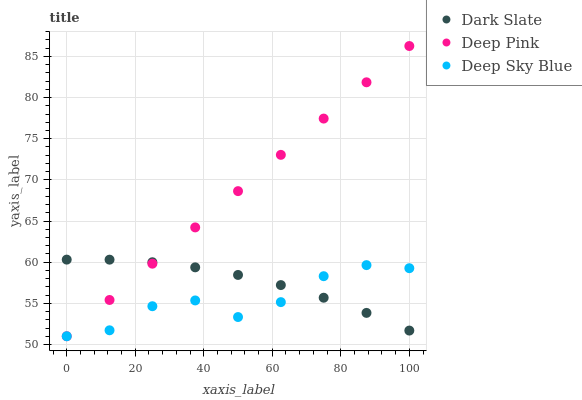Does Deep Sky Blue have the minimum area under the curve?
Answer yes or no. Yes. Does Deep Pink have the maximum area under the curve?
Answer yes or no. Yes. Does Deep Pink have the minimum area under the curve?
Answer yes or no. No. Does Deep Sky Blue have the maximum area under the curve?
Answer yes or no. No. Is Deep Pink the smoothest?
Answer yes or no. Yes. Is Deep Sky Blue the roughest?
Answer yes or no. Yes. Is Deep Sky Blue the smoothest?
Answer yes or no. No. Is Deep Pink the roughest?
Answer yes or no. No. Does Deep Pink have the lowest value?
Answer yes or no. Yes. Does Deep Pink have the highest value?
Answer yes or no. Yes. Does Deep Sky Blue have the highest value?
Answer yes or no. No. Does Deep Pink intersect Dark Slate?
Answer yes or no. Yes. Is Deep Pink less than Dark Slate?
Answer yes or no. No. Is Deep Pink greater than Dark Slate?
Answer yes or no. No. 